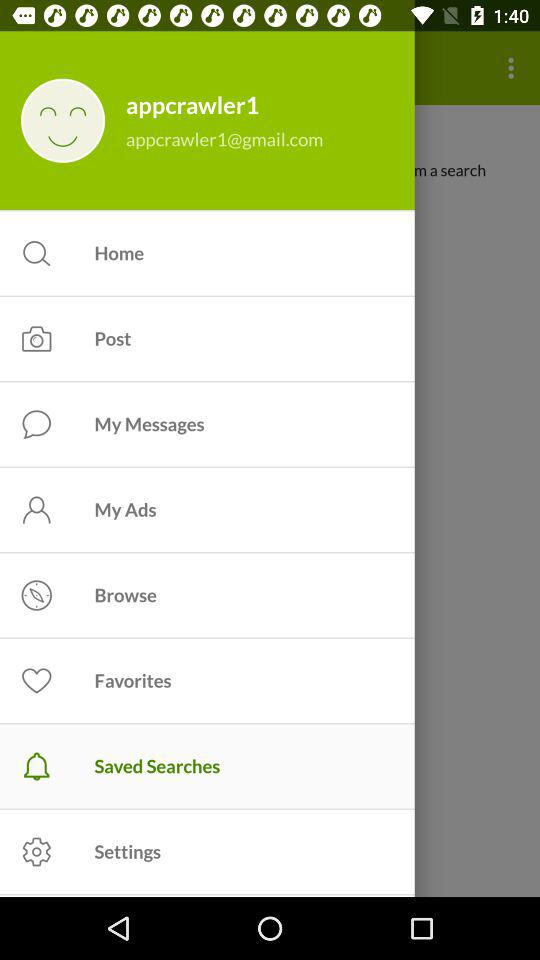What option is selected? The selected option is saved searches. 